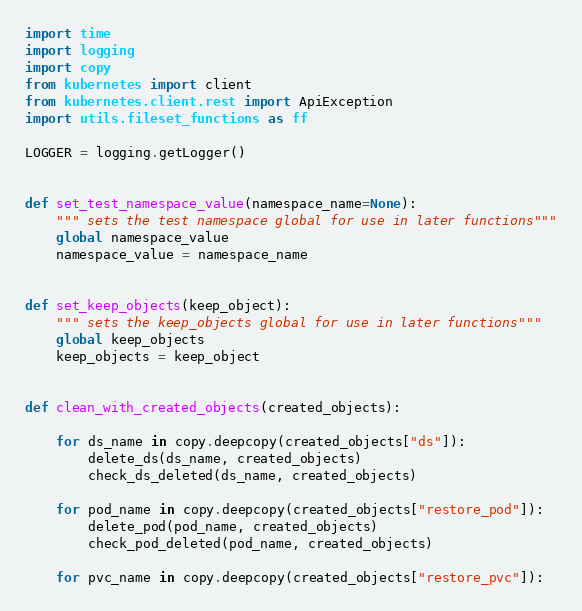Convert code to text. <code><loc_0><loc_0><loc_500><loc_500><_Python_>import time
import logging
import copy
from kubernetes import client
from kubernetes.client.rest import ApiException
import utils.fileset_functions as ff

LOGGER = logging.getLogger()


def set_test_namespace_value(namespace_name=None):
    """ sets the test namespace global for use in later functions"""
    global namespace_value
    namespace_value = namespace_name


def set_keep_objects(keep_object):
    """ sets the keep_objects global for use in later functions"""
    global keep_objects
    keep_objects = keep_object


def clean_with_created_objects(created_objects):

    for ds_name in copy.deepcopy(created_objects["ds"]):
        delete_ds(ds_name, created_objects)
        check_ds_deleted(ds_name, created_objects)

    for pod_name in copy.deepcopy(created_objects["restore_pod"]):
        delete_pod(pod_name, created_objects)
        check_pod_deleted(pod_name, created_objects)

    for pvc_name in copy.deepcopy(created_objects["restore_pvc"]):</code> 